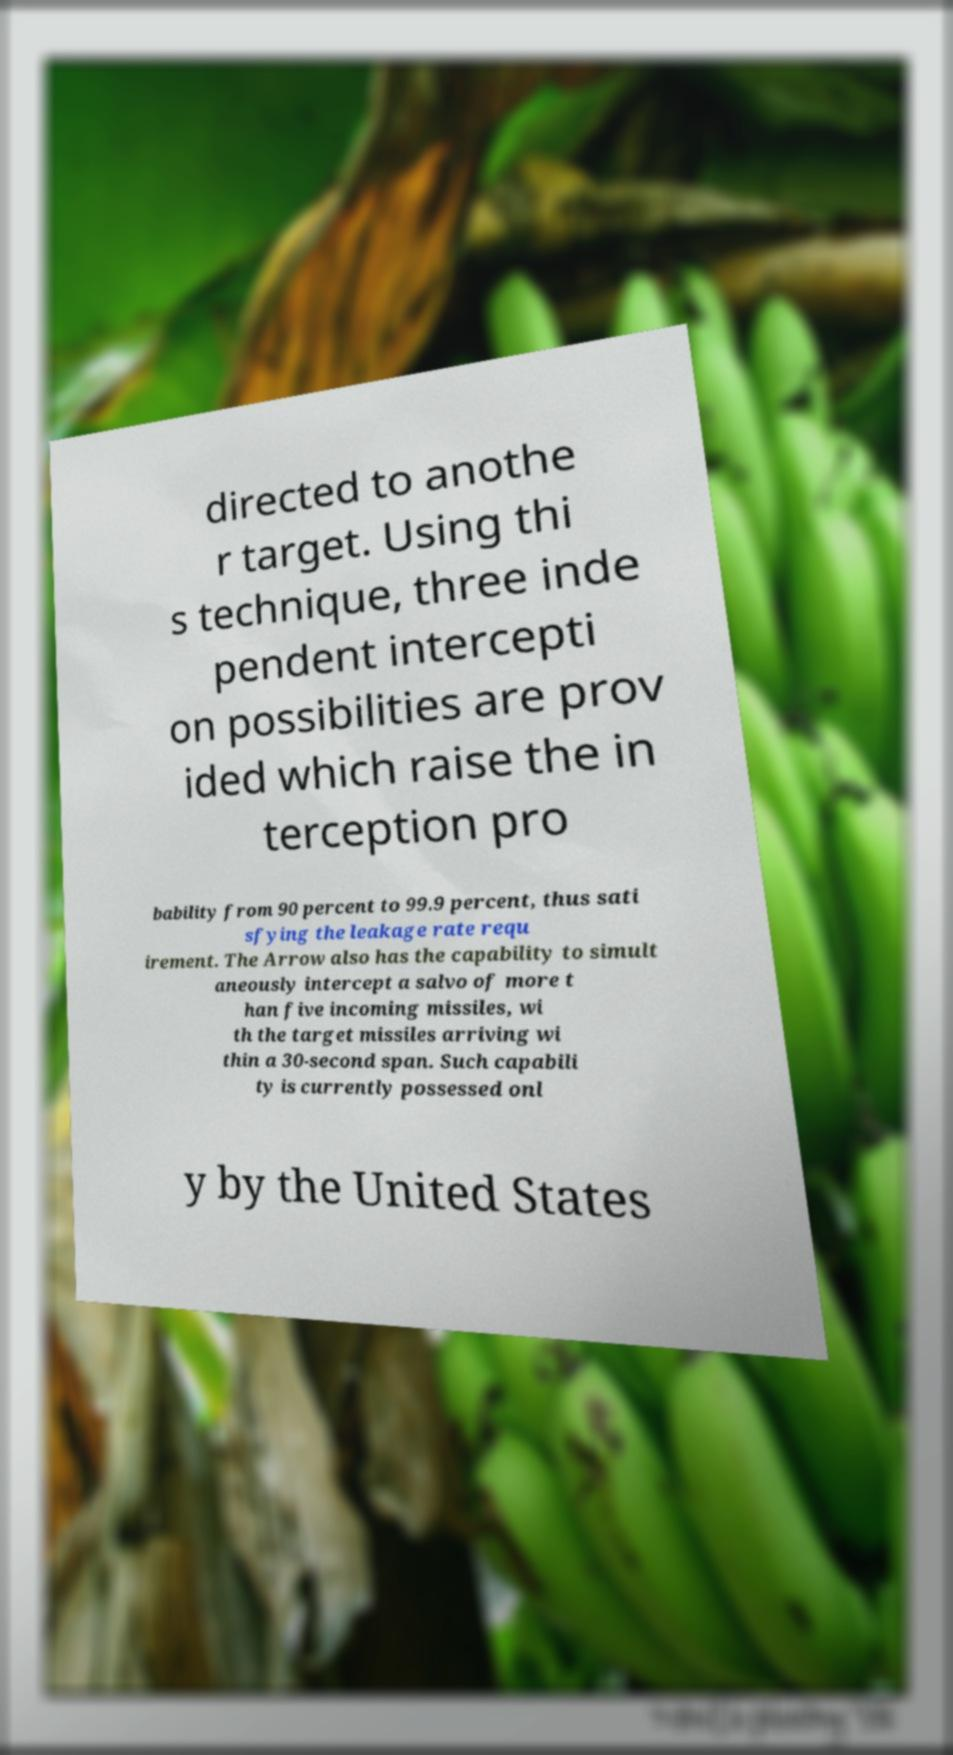Can you accurately transcribe the text from the provided image for me? directed to anothe r target. Using thi s technique, three inde pendent intercepti on possibilities are prov ided which raise the in terception pro bability from 90 percent to 99.9 percent, thus sati sfying the leakage rate requ irement. The Arrow also has the capability to simult aneously intercept a salvo of more t han five incoming missiles, wi th the target missiles arriving wi thin a 30-second span. Such capabili ty is currently possessed onl y by the United States 